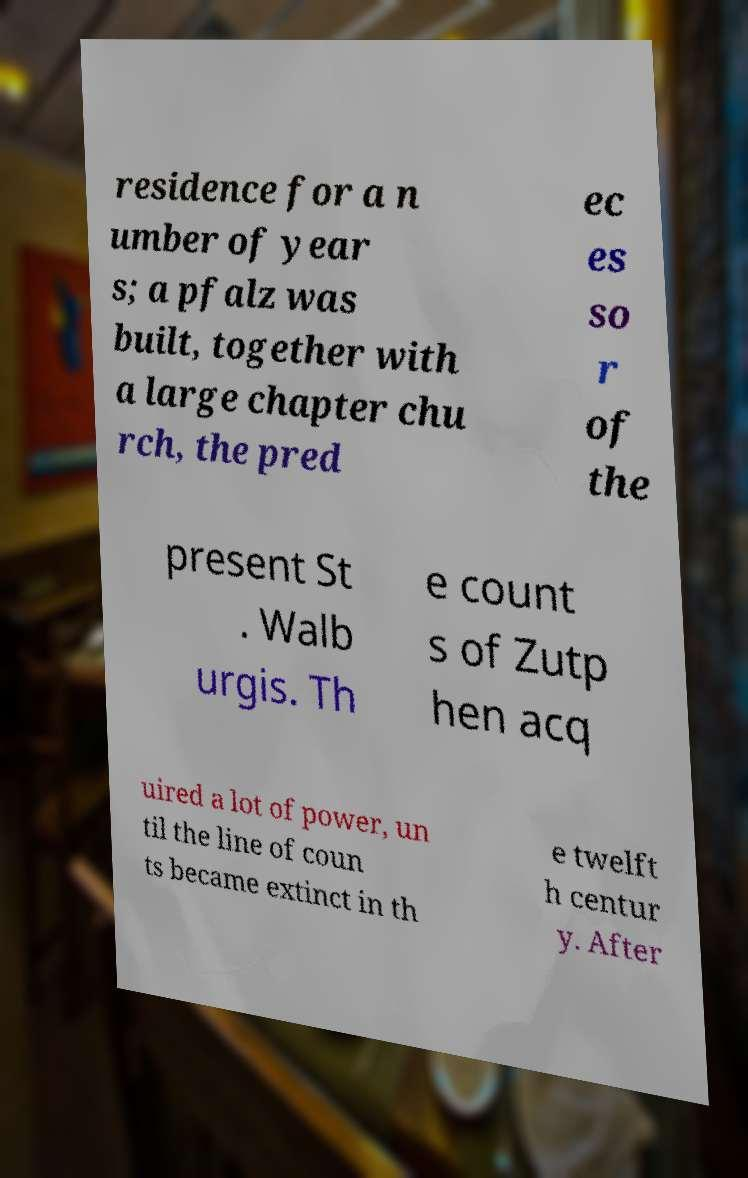What messages or text are displayed in this image? I need them in a readable, typed format. residence for a n umber of year s; a pfalz was built, together with a large chapter chu rch, the pred ec es so r of the present St . Walb urgis. Th e count s of Zutp hen acq uired a lot of power, un til the line of coun ts became extinct in th e twelft h centur y. After 